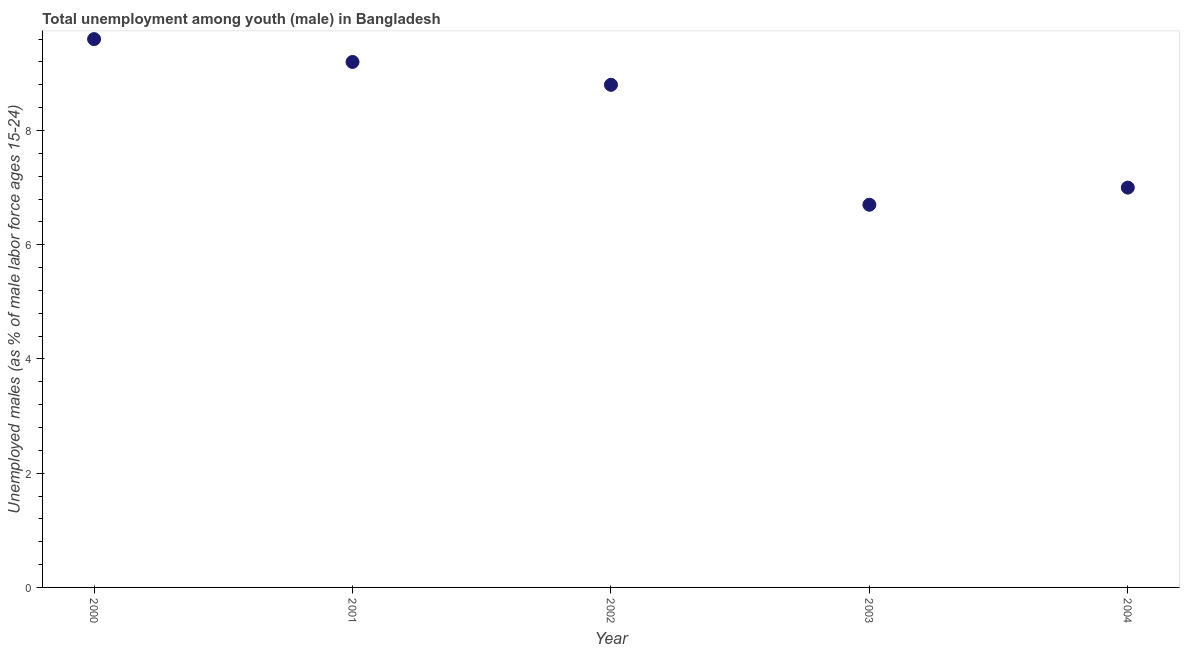Across all years, what is the maximum unemployed male youth population?
Ensure brevity in your answer.  9.6. Across all years, what is the minimum unemployed male youth population?
Provide a short and direct response. 6.7. In which year was the unemployed male youth population maximum?
Your answer should be very brief. 2000. What is the sum of the unemployed male youth population?
Offer a very short reply. 41.3. What is the difference between the unemployed male youth population in 2000 and 2001?
Your answer should be compact. 0.4. What is the average unemployed male youth population per year?
Offer a very short reply. 8.26. What is the median unemployed male youth population?
Your response must be concise. 8.8. In how many years, is the unemployed male youth population greater than 3.6 %?
Give a very brief answer. 5. What is the ratio of the unemployed male youth population in 2002 to that in 2003?
Provide a short and direct response. 1.31. Is the unemployed male youth population in 2000 less than that in 2001?
Make the answer very short. No. What is the difference between the highest and the second highest unemployed male youth population?
Offer a very short reply. 0.4. What is the difference between the highest and the lowest unemployed male youth population?
Provide a succinct answer. 2.9. How many dotlines are there?
Offer a terse response. 1. How many years are there in the graph?
Give a very brief answer. 5. What is the difference between two consecutive major ticks on the Y-axis?
Keep it short and to the point. 2. What is the title of the graph?
Offer a very short reply. Total unemployment among youth (male) in Bangladesh. What is the label or title of the X-axis?
Your answer should be compact. Year. What is the label or title of the Y-axis?
Give a very brief answer. Unemployed males (as % of male labor force ages 15-24). What is the Unemployed males (as % of male labor force ages 15-24) in 2000?
Offer a terse response. 9.6. What is the Unemployed males (as % of male labor force ages 15-24) in 2001?
Ensure brevity in your answer.  9.2. What is the Unemployed males (as % of male labor force ages 15-24) in 2002?
Your response must be concise. 8.8. What is the Unemployed males (as % of male labor force ages 15-24) in 2003?
Your response must be concise. 6.7. What is the Unemployed males (as % of male labor force ages 15-24) in 2004?
Your answer should be compact. 7. What is the difference between the Unemployed males (as % of male labor force ages 15-24) in 2000 and 2004?
Ensure brevity in your answer.  2.6. What is the difference between the Unemployed males (as % of male labor force ages 15-24) in 2001 and 2003?
Make the answer very short. 2.5. What is the difference between the Unemployed males (as % of male labor force ages 15-24) in 2001 and 2004?
Keep it short and to the point. 2.2. What is the difference between the Unemployed males (as % of male labor force ages 15-24) in 2002 and 2003?
Provide a succinct answer. 2.1. What is the difference between the Unemployed males (as % of male labor force ages 15-24) in 2003 and 2004?
Give a very brief answer. -0.3. What is the ratio of the Unemployed males (as % of male labor force ages 15-24) in 2000 to that in 2001?
Keep it short and to the point. 1.04. What is the ratio of the Unemployed males (as % of male labor force ages 15-24) in 2000 to that in 2002?
Provide a succinct answer. 1.09. What is the ratio of the Unemployed males (as % of male labor force ages 15-24) in 2000 to that in 2003?
Provide a short and direct response. 1.43. What is the ratio of the Unemployed males (as % of male labor force ages 15-24) in 2000 to that in 2004?
Your response must be concise. 1.37. What is the ratio of the Unemployed males (as % of male labor force ages 15-24) in 2001 to that in 2002?
Your response must be concise. 1.04. What is the ratio of the Unemployed males (as % of male labor force ages 15-24) in 2001 to that in 2003?
Give a very brief answer. 1.37. What is the ratio of the Unemployed males (as % of male labor force ages 15-24) in 2001 to that in 2004?
Offer a very short reply. 1.31. What is the ratio of the Unemployed males (as % of male labor force ages 15-24) in 2002 to that in 2003?
Ensure brevity in your answer.  1.31. What is the ratio of the Unemployed males (as % of male labor force ages 15-24) in 2002 to that in 2004?
Your answer should be compact. 1.26. 